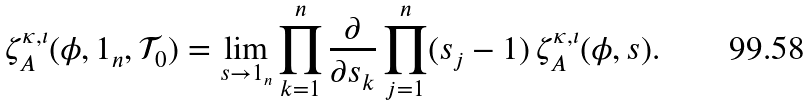Convert formula to latex. <formula><loc_0><loc_0><loc_500><loc_500>\zeta _ { A } ^ { \kappa , \iota } ( \phi , 1 _ { n } , \mathcal { T } _ { 0 } ) = \lim _ { s \to 1 _ { n } } \prod _ { k = 1 } ^ { n } \frac { \partial } { \partial s _ { k } } \prod _ { j = 1 } ^ { n } ( s _ { j } - 1 ) \, \zeta _ { A } ^ { \kappa , \iota } ( \phi , s ) .</formula> 